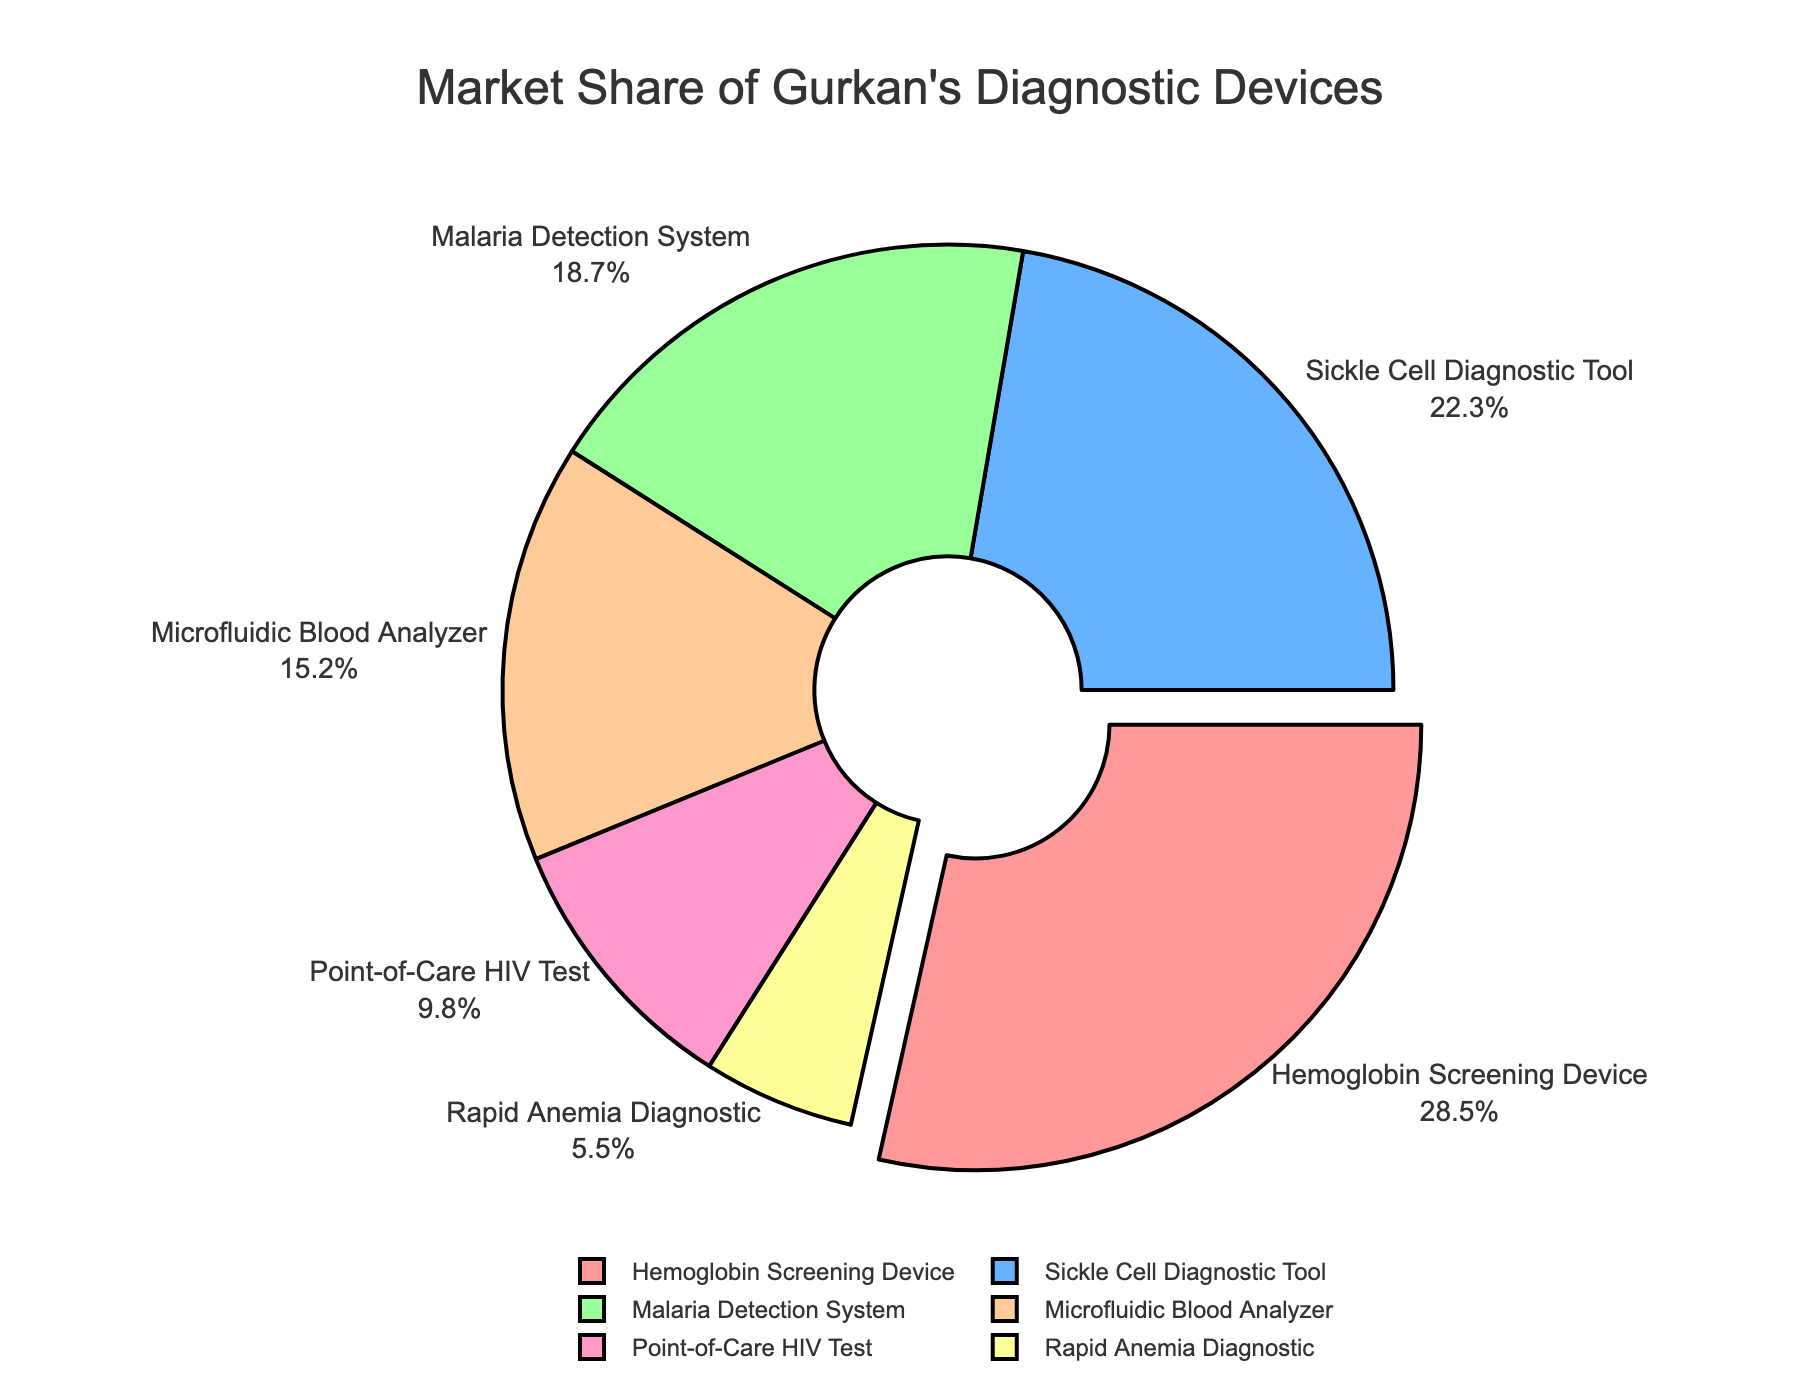Which diagnostic device has the largest market share? The device with the largest market share is the one represented by the largest slice in the pie chart.
Answer: Hemoglobin Screening Device What percentage of the market share is held by the Sickle Cell Diagnostic Tool and the Microfluidic Blood Analyzer combined? The market share of the Sickle Cell Diagnostic Tool is 22.3%, and the Microfluidic Blood Analyzer is 15.2%. Adding these, 22.3% + 15.2%, gives the combined share.
Answer: 37.5% How does the market share of the Point-of-Care HIV Test compare to the Rapid Anemia Diagnostic? The market share of the Point-of-Care HIV Test is 9.8%, whereas the Rapid Anemia Diagnostic is 5.5%. The Point-of-Care HIV Test has a higher market share than the Rapid Anemia Diagnostic.
Answer: Point-of-Care HIV Test > Rapid Anemia Diagnostic What percentage of the market share is held by devices other than the top three? The top three devices are Hemoglobin Screening Device (28.5%), Sickle Cell Diagnostic Tool (22.3%), and Malaria Detection System (18.7%). Summing these gives 28.5% + 22.3% + 18.7% = 69.5%. Subtracting this from 100% gives the market share of the other devices: 100% - 69.5%.
Answer: 30.5% What is the color associated with the Hemoglobin Screening Device in the pie chart? The Hemoglobin Screening Device is represented by the largest slice, which is typically highlighted or pulled out. The color of this slice is identified visually in the pie chart.
Answer: Red Which device has the smallest market share, and what is the percentage? The smallest slice in the pie chart corresponds to the Rapid Anemia Diagnostic, which has the smallest market share.
Answer: Rapid Anemia Diagnostic, 5.5% If the market share of the Malaria Detection System increased by 5%, what would its new market share be? The current market share of the Malaria Detection System is 18.7%. Adding 5% to this gives 18.7% + 5%.
Answer: 23.7% Compare the total market share of devices related to blood analysis (Hemoglobin Screening Device, Microfluidic Blood Analyzer, Rapid Anemia Diagnostic). Summing the market shares of these devices: Hemoglobin Screening Device (28.5%), Microfluidic Blood Analyzer (15.2%), and Rapid Anemia Diagnostic (5.5%) gives 28.5% + 15.2% + 5.5%.
Answer: 49.2% Which two devices have market shares that sum to approximately equal to that of the Hemoglobin Screening Device? The Hemoglobin Screening Device has a market share of 28.5%. The two devices whose market shares sum close to this are the Sickle Cell Diagnostic Tool (22.3%) and the Rapid Anemia Diagnostic (5.5%). Their sum, 22.3% + 5.5%, is approximately equal to 28.5%.
Answer: Sickle Cell Diagnostic Tool and Rapid Anemia Diagnostic Rank the devices in descending order of their market share. The devices need to be ordered based on their market share percentages from highest to lowest: Hemoglobin Screening Device (28.5%), Sickle Cell Diagnostic Tool (22.3%), Malaria Detection System (18.7%), Microfluidic Blood Analyzer (15.2%), Point-of-Care HIV Test (9.8%), Rapid Anemia Diagnostic (5.5%).
Answer: Hemoglobin Screening Device, Sickle Cell Diagnostic Tool, Malaria Detection System, Microfluidic Blood Analyzer, Point-of-Care HIV Test, Rapid Anemia Diagnostic 